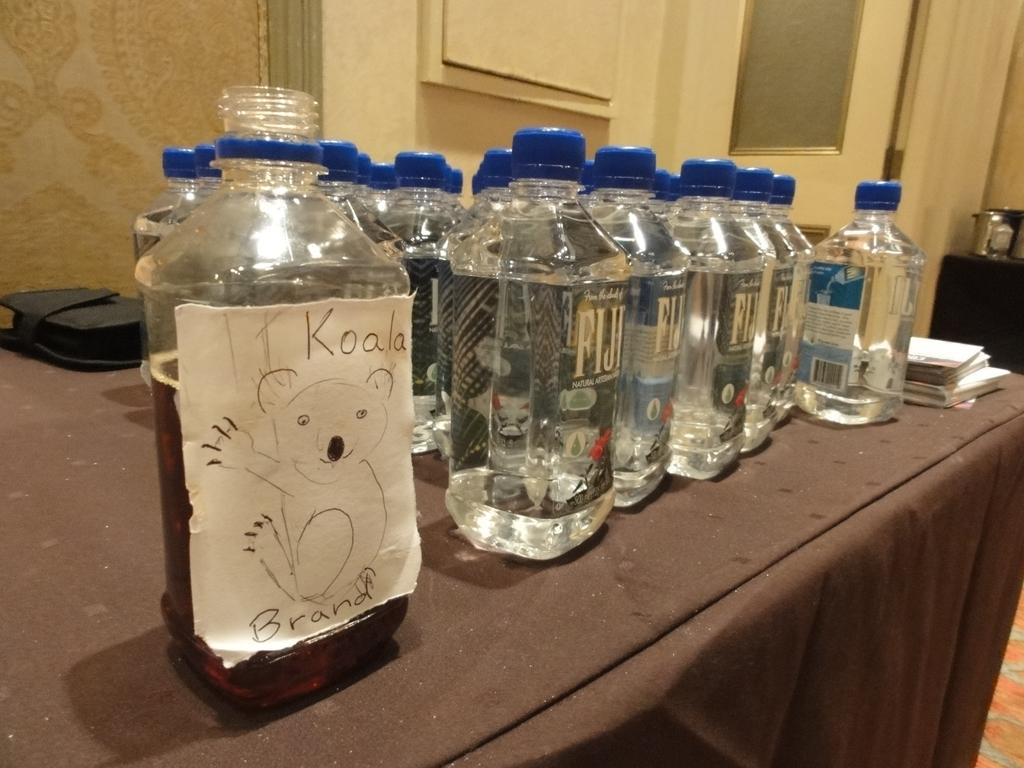Provide a one-sentence caption for the provided image. A table with bottles of Fiji water on it and then a bottle with a handwritten label saying Koala brand. 